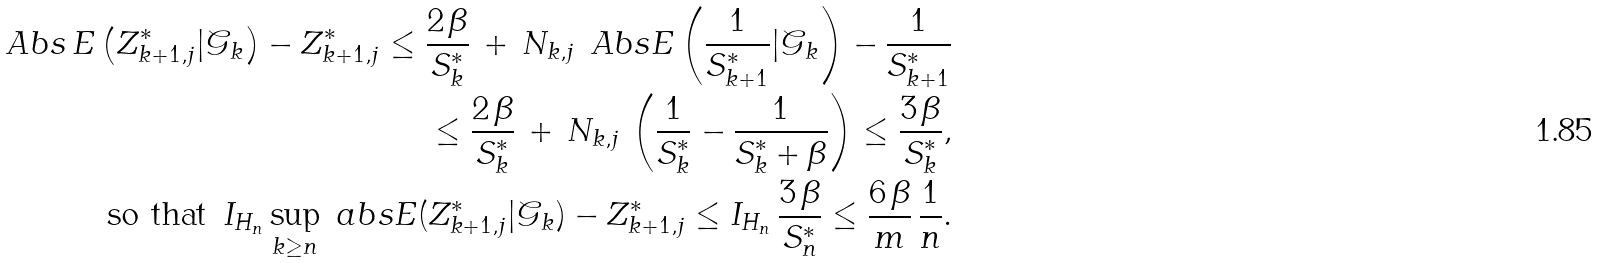Convert formula to latex. <formula><loc_0><loc_0><loc_500><loc_500>\ A b s { \, E \left ( Z _ { k + 1 , j } ^ { * } | \mathcal { G } _ { k } \right ) - Z _ { k + 1 , j } ^ { * } } \leq \frac { 2 \, \beta } { S _ { k } ^ { * } } \, + \, N _ { k , j } \, \ A b s { E \left ( \frac { 1 } { S _ { k + 1 } ^ { * } } | \mathcal { G } _ { k } \right ) - \frac { 1 } { S _ { k + 1 } ^ { * } } } \\ \leq \frac { 2 \, \beta } { S _ { k } ^ { * } } \, + \, N _ { k , j } \, \left ( \frac { 1 } { S _ { k } ^ { * } } - \frac { 1 } { S _ { k } ^ { * } + \beta } \right ) \leq \frac { 3 \, \beta } { S _ { k } ^ { * } } , \\ \text {so that } \, I _ { H _ { n } } \sup _ { k \geq n } \ a b s { E ( Z _ { k + 1 , j } ^ { * } | \mathcal { G } _ { k } ) - Z _ { k + 1 , j } ^ { * } } \leq I _ { H _ { n } } \, \frac { 3 \, \beta } { S _ { n } ^ { * } } \leq \frac { 6 \, \beta } { m } \, \frac { 1 } { n } .</formula> 